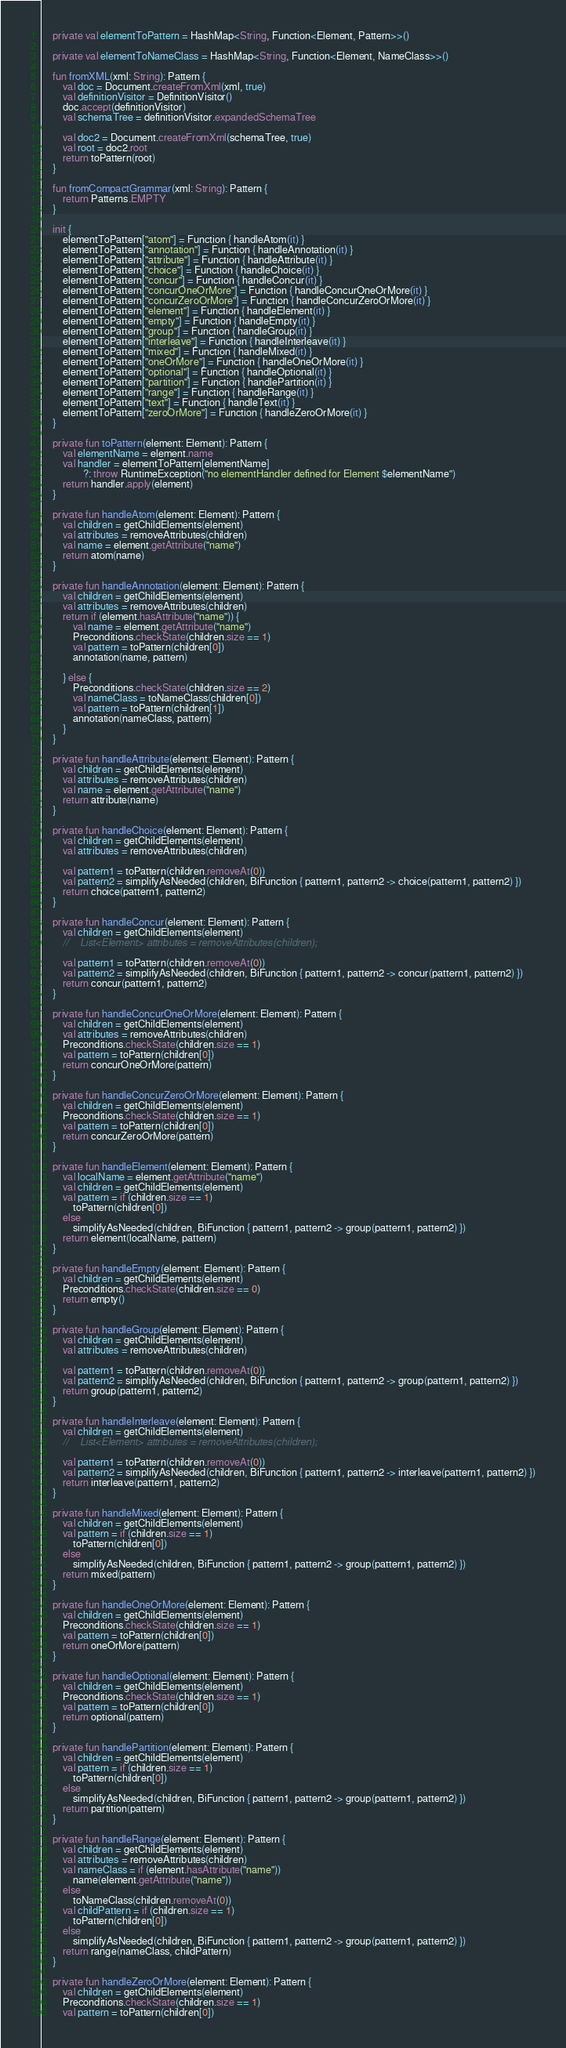Convert code to text. <code><loc_0><loc_0><loc_500><loc_500><_Kotlin_>
    private val elementToPattern = HashMap<String, Function<Element, Pattern>>()

    private val elementToNameClass = HashMap<String, Function<Element, NameClass>>()

    fun fromXML(xml: String): Pattern {
        val doc = Document.createFromXml(xml, true)
        val definitionVisitor = DefinitionVisitor()
        doc.accept(definitionVisitor)
        val schemaTree = definitionVisitor.expandedSchemaTree

        val doc2 = Document.createFromXml(schemaTree, true)
        val root = doc2.root
        return toPattern(root)
    }

    fun fromCompactGrammar(xml: String): Pattern {
        return Patterns.EMPTY
    }

    init {
        elementToPattern["atom"] = Function { handleAtom(it) }
        elementToPattern["annotation"] = Function { handleAnnotation(it) }
        elementToPattern["attribute"] = Function { handleAttribute(it) }
        elementToPattern["choice"] = Function { handleChoice(it) }
        elementToPattern["concur"] = Function { handleConcur(it) }
        elementToPattern["concurOneOrMore"] = Function { handleConcurOneOrMore(it) }
        elementToPattern["concurZeroOrMore"] = Function { handleConcurZeroOrMore(it) }
        elementToPattern["element"] = Function { handleElement(it) }
        elementToPattern["empty"] = Function { handleEmpty(it) }
        elementToPattern["group"] = Function { handleGroup(it) }
        elementToPattern["interleave"] = Function { handleInterleave(it) }
        elementToPattern["mixed"] = Function { handleMixed(it) }
        elementToPattern["oneOrMore"] = Function { handleOneOrMore(it) }
        elementToPattern["optional"] = Function { handleOptional(it) }
        elementToPattern["partition"] = Function { handlePartition(it) }
        elementToPattern["range"] = Function { handleRange(it) }
        elementToPattern["text"] = Function { handleText(it) }
        elementToPattern["zeroOrMore"] = Function { handleZeroOrMore(it) }
    }

    private fun toPattern(element: Element): Pattern {
        val elementName = element.name
        val handler = elementToPattern[elementName]
                ?: throw RuntimeException("no elementHandler defined for Element $elementName")
        return handler.apply(element)
    }

    private fun handleAtom(element: Element): Pattern {
        val children = getChildElements(element)
        val attributes = removeAttributes(children)
        val name = element.getAttribute("name")
        return atom(name)
    }

    private fun handleAnnotation(element: Element): Pattern {
        val children = getChildElements(element)
        val attributes = removeAttributes(children)
        return if (element.hasAttribute("name")) {
            val name = element.getAttribute("name")
            Preconditions.checkState(children.size == 1)
            val pattern = toPattern(children[0])
            annotation(name, pattern)

        } else {
            Preconditions.checkState(children.size == 2)
            val nameClass = toNameClass(children[0])
            val pattern = toPattern(children[1])
            annotation(nameClass, pattern)
        }
    }

    private fun handleAttribute(element: Element): Pattern {
        val children = getChildElements(element)
        val attributes = removeAttributes(children)
        val name = element.getAttribute("name")
        return attribute(name)
    }

    private fun handleChoice(element: Element): Pattern {
        val children = getChildElements(element)
        val attributes = removeAttributes(children)

        val pattern1 = toPattern(children.removeAt(0))
        val pattern2 = simplifyAsNeeded(children, BiFunction { pattern1, pattern2 -> choice(pattern1, pattern2) })
        return choice(pattern1, pattern2)
    }

    private fun handleConcur(element: Element): Pattern {
        val children = getChildElements(element)
        //    List<Element> attributes = removeAttributes(children);

        val pattern1 = toPattern(children.removeAt(0))
        val pattern2 = simplifyAsNeeded(children, BiFunction { pattern1, pattern2 -> concur(pattern1, pattern2) })
        return concur(pattern1, pattern2)
    }

    private fun handleConcurOneOrMore(element: Element): Pattern {
        val children = getChildElements(element)
        val attributes = removeAttributes(children)
        Preconditions.checkState(children.size == 1)
        val pattern = toPattern(children[0])
        return concurOneOrMore(pattern)
    }

    private fun handleConcurZeroOrMore(element: Element): Pattern {
        val children = getChildElements(element)
        Preconditions.checkState(children.size == 1)
        val pattern = toPattern(children[0])
        return concurZeroOrMore(pattern)
    }

    private fun handleElement(element: Element): Pattern {
        val localName = element.getAttribute("name")
        val children = getChildElements(element)
        val pattern = if (children.size == 1)
            toPattern(children[0])
        else
            simplifyAsNeeded(children, BiFunction { pattern1, pattern2 -> group(pattern1, pattern2) })
        return element(localName, pattern)
    }

    private fun handleEmpty(element: Element): Pattern {
        val children = getChildElements(element)
        Preconditions.checkState(children.size == 0)
        return empty()
    }

    private fun handleGroup(element: Element): Pattern {
        val children = getChildElements(element)
        val attributes = removeAttributes(children)

        val pattern1 = toPattern(children.removeAt(0))
        val pattern2 = simplifyAsNeeded(children, BiFunction { pattern1, pattern2 -> group(pattern1, pattern2) })
        return group(pattern1, pattern2)
    }

    private fun handleInterleave(element: Element): Pattern {
        val children = getChildElements(element)
        //    List<Element> attributes = removeAttributes(children);

        val pattern1 = toPattern(children.removeAt(0))
        val pattern2 = simplifyAsNeeded(children, BiFunction { pattern1, pattern2 -> interleave(pattern1, pattern2) })
        return interleave(pattern1, pattern2)
    }

    private fun handleMixed(element: Element): Pattern {
        val children = getChildElements(element)
        val pattern = if (children.size == 1)
            toPattern(children[0])
        else
            simplifyAsNeeded(children, BiFunction { pattern1, pattern2 -> group(pattern1, pattern2) })
        return mixed(pattern)
    }

    private fun handleOneOrMore(element: Element): Pattern {
        val children = getChildElements(element)
        Preconditions.checkState(children.size == 1)
        val pattern = toPattern(children[0])
        return oneOrMore(pattern)
    }

    private fun handleOptional(element: Element): Pattern {
        val children = getChildElements(element)
        Preconditions.checkState(children.size == 1)
        val pattern = toPattern(children[0])
        return optional(pattern)
    }

    private fun handlePartition(element: Element): Pattern {
        val children = getChildElements(element)
        val pattern = if (children.size == 1)
            toPattern(children[0])
        else
            simplifyAsNeeded(children, BiFunction { pattern1, pattern2 -> group(pattern1, pattern2) })
        return partition(pattern)
    }

    private fun handleRange(element: Element): Pattern {
        val children = getChildElements(element)
        val attributes = removeAttributes(children)
        val nameClass = if (element.hasAttribute("name"))
            name(element.getAttribute("name"))
        else
            toNameClass(children.removeAt(0))
        val childPattern = if (children.size == 1)
            toPattern(children[0])
        else
            simplifyAsNeeded(children, BiFunction { pattern1, pattern2 -> group(pattern1, pattern2) })
        return range(nameClass, childPattern)
    }

    private fun handleZeroOrMore(element: Element): Pattern {
        val children = getChildElements(element)
        Preconditions.checkState(children.size == 1)
        val pattern = toPattern(children[0])</code> 